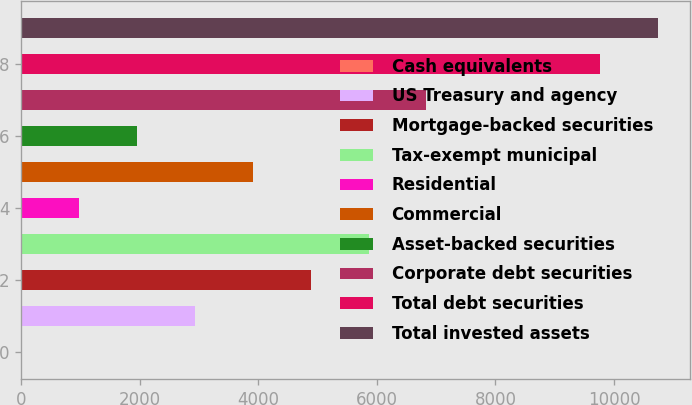Convert chart. <chart><loc_0><loc_0><loc_500><loc_500><bar_chart><fcel>Cash equivalents<fcel>US Treasury and agency<fcel>Mortgage-backed securities<fcel>Tax-exempt municipal<fcel>Residential<fcel>Commercial<fcel>Asset-backed securities<fcel>Corporate debt securities<fcel>Total debt securities<fcel>Total invested assets<nl><fcel>3.96<fcel>2931.66<fcel>4883.46<fcel>5859.36<fcel>979.86<fcel>3907.56<fcel>1955.76<fcel>6835.26<fcel>9763<fcel>10738.9<nl></chart> 